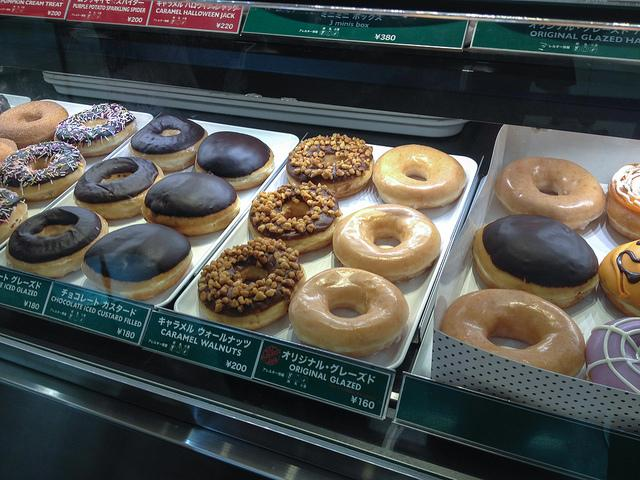Where can you buy these donuts? Please explain your reasoning. japan. The donuts are in japan. 